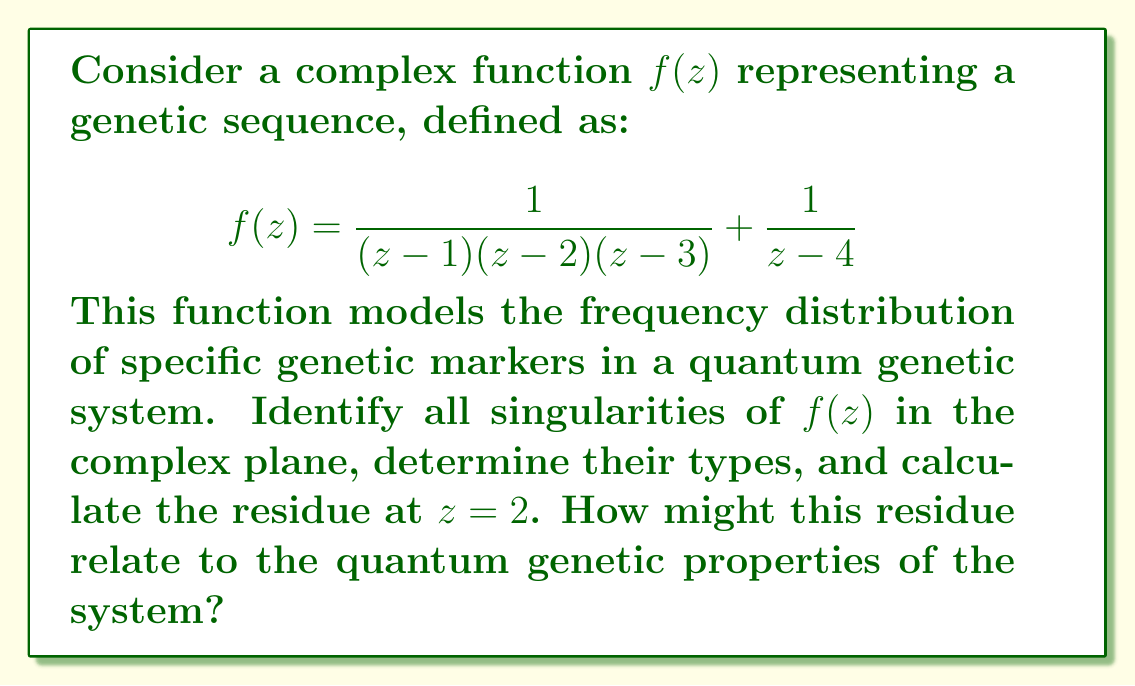Provide a solution to this math problem. 1) First, let's identify the singularities of $f(z)$:
   The function has singularities at $z = 1, 2, 3,$ and $4$.

2) To determine the type of singularities:
   - At $z = 1, 3,$ and $4$, we have simple poles (order 1).
   - At $z = 2$, we have a double pole (order 2) due to the term $(z-2)$ in the denominator of the first fraction.

3) To calculate the residue at $z=2$, we use the formula for the residue of a double pole:
   $$\text{Res}(f,2) = \lim_{z \to 2} \frac{d}{dz}[(z-2)^2f(z)]$$

4) Let's simplify $f(z)$ around $z=2$:
   $$f(z) = \frac{1}{(z-1)(z-3)} \cdot \frac{1}{z-2} + \frac{1}{z-4}$$

5) Now, let's calculate the limit:
   $$\begin{align}
   \text{Res}(f,2) &= \lim_{z \to 2} \frac{d}{dz}\left[\frac{z-2}{(z-1)(z-3)} + \frac{(z-2)^2}{z-4}\right] \\
   &= \lim_{z \to 2} \left[\frac{(z-1)(z-3) - (z-2)((z-3)+(z-1))}{((z-1)(z-3))^2} + \frac{2(z-2)(z-4) - (z-2)^2}{(z-4)^2}\right] \\
   &= \frac{(2-1)(2-3) - 0}{((2-1)(2-3))^2} + \frac{0}{(2-4)^2} \\
   &= \frac{-1}{(-1)^2} = -1
   \end{align}$$

6) In the context of quantum genetics, this residue of -1 at $z=2$ could represent:
   - A critical genetic marker frequency in the quantum system
   - A measure of genetic instability or mutation rate at this specific locus
   - An indicator of quantum entanglement between genetic elements

The analysis of such residues in complex plane representations of genetic sequences can provide insights into the quantum behavior of genetic systems, potentially revealing hidden patterns or correlations in genetic data that are not apparent in classical genetic analysis.
Answer: Residue at $z=2$ is $-1$, representing a critical quantum genetic property. 